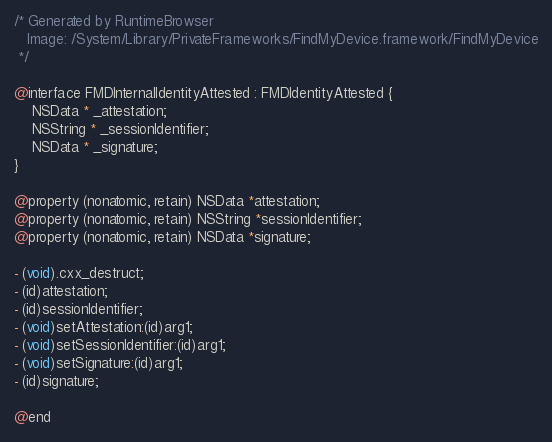Convert code to text. <code><loc_0><loc_0><loc_500><loc_500><_C_>/* Generated by RuntimeBrowser
   Image: /System/Library/PrivateFrameworks/FindMyDevice.framework/FindMyDevice
 */

@interface FMDInternalIdentityAttested : FMDIdentityAttested {
    NSData * _attestation;
    NSString * _sessionIdentifier;
    NSData * _signature;
}

@property (nonatomic, retain) NSData *attestation;
@property (nonatomic, retain) NSString *sessionIdentifier;
@property (nonatomic, retain) NSData *signature;

- (void).cxx_destruct;
- (id)attestation;
- (id)sessionIdentifier;
- (void)setAttestation:(id)arg1;
- (void)setSessionIdentifier:(id)arg1;
- (void)setSignature:(id)arg1;
- (id)signature;

@end
</code> 